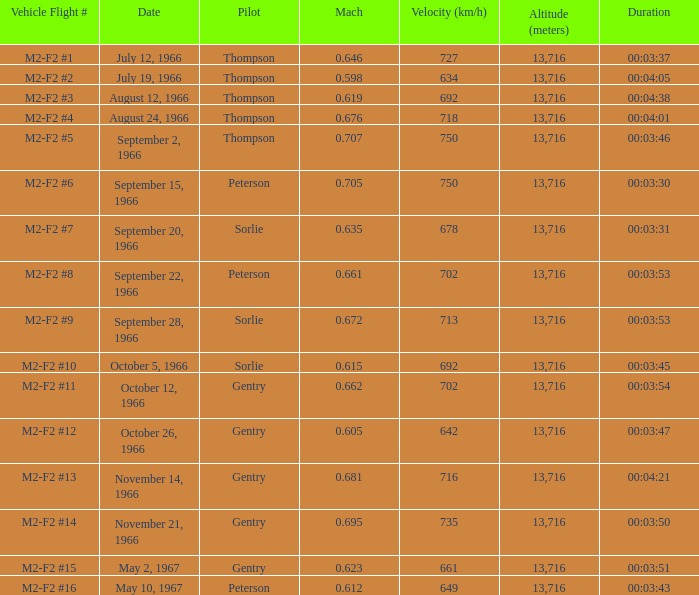What Date has a Mach of 0.662? October 12, 1966. 